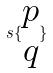Convert formula to latex. <formula><loc_0><loc_0><loc_500><loc_500>s \{ \begin{matrix} p \\ q \end{matrix} \}</formula> 